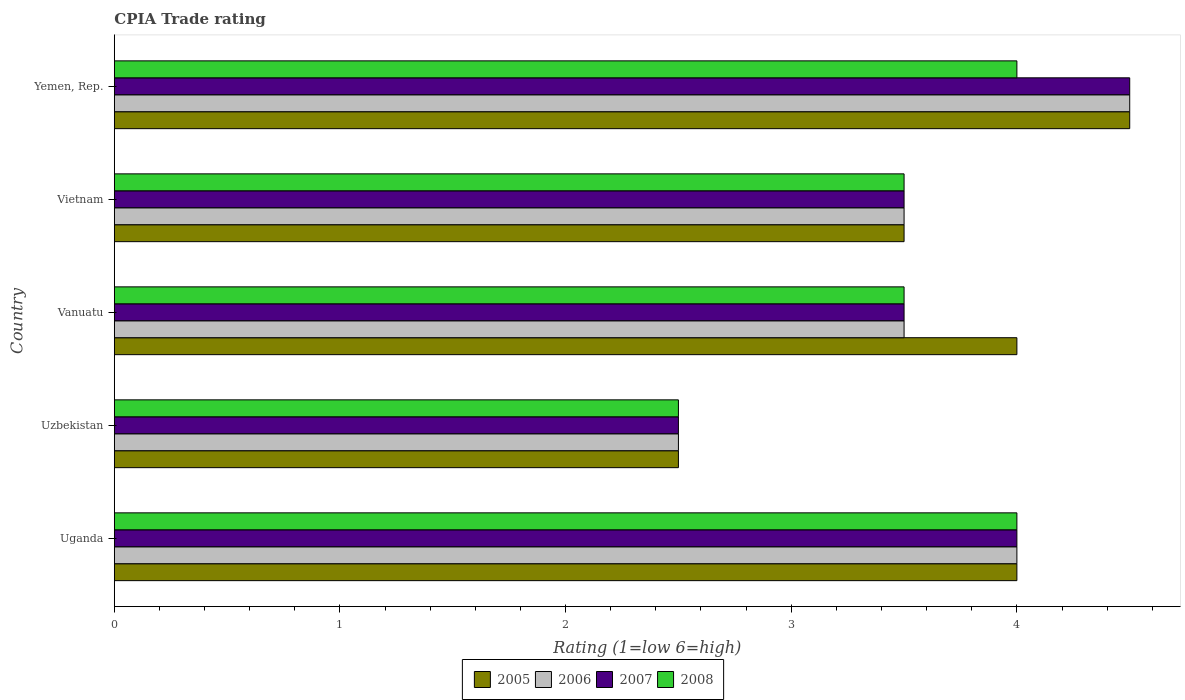How many different coloured bars are there?
Give a very brief answer. 4. How many groups of bars are there?
Keep it short and to the point. 5. Are the number of bars per tick equal to the number of legend labels?
Your answer should be compact. Yes. Are the number of bars on each tick of the Y-axis equal?
Keep it short and to the point. Yes. How many bars are there on the 1st tick from the top?
Provide a succinct answer. 4. What is the label of the 5th group of bars from the top?
Make the answer very short. Uganda. In how many cases, is the number of bars for a given country not equal to the number of legend labels?
Your response must be concise. 0. What is the CPIA rating in 2007 in Uzbekistan?
Your answer should be compact. 2.5. In which country was the CPIA rating in 2005 maximum?
Keep it short and to the point. Yemen, Rep. In which country was the CPIA rating in 2005 minimum?
Your response must be concise. Uzbekistan. What is the total CPIA rating in 2005 in the graph?
Your answer should be very brief. 18.5. What is the difference between the CPIA rating in 2006 in Uganda and the CPIA rating in 2005 in Vanuatu?
Your response must be concise. 0. What is the average CPIA rating in 2005 per country?
Give a very brief answer. 3.7. What is the difference between the CPIA rating in 2008 and CPIA rating in 2005 in Vanuatu?
Your answer should be very brief. -0.5. In how many countries, is the CPIA rating in 2008 greater than 0.2 ?
Offer a very short reply. 5. What is the ratio of the CPIA rating in 2007 in Uganda to that in Vanuatu?
Provide a succinct answer. 1.14. What is the difference between the highest and the second highest CPIA rating in 2007?
Offer a very short reply. 0.5. What is the difference between the highest and the lowest CPIA rating in 2008?
Provide a succinct answer. 1.5. What does the 4th bar from the top in Yemen, Rep. represents?
Your response must be concise. 2005. What does the 4th bar from the bottom in Uzbekistan represents?
Your answer should be very brief. 2008. Are all the bars in the graph horizontal?
Make the answer very short. Yes. How many countries are there in the graph?
Provide a succinct answer. 5. Does the graph contain any zero values?
Provide a succinct answer. No. Where does the legend appear in the graph?
Your answer should be compact. Bottom center. How many legend labels are there?
Make the answer very short. 4. How are the legend labels stacked?
Offer a terse response. Horizontal. What is the title of the graph?
Your answer should be very brief. CPIA Trade rating. Does "2015" appear as one of the legend labels in the graph?
Give a very brief answer. No. What is the label or title of the Y-axis?
Your answer should be very brief. Country. What is the Rating (1=low 6=high) of 2005 in Uzbekistan?
Make the answer very short. 2.5. What is the Rating (1=low 6=high) of 2006 in Uzbekistan?
Offer a terse response. 2.5. What is the Rating (1=low 6=high) in 2007 in Uzbekistan?
Your answer should be compact. 2.5. What is the Rating (1=low 6=high) in 2007 in Vanuatu?
Keep it short and to the point. 3.5. What is the Rating (1=low 6=high) in 2008 in Vanuatu?
Your answer should be compact. 3.5. What is the Rating (1=low 6=high) in 2006 in Vietnam?
Your answer should be very brief. 3.5. What is the Rating (1=low 6=high) of 2008 in Vietnam?
Your response must be concise. 3.5. What is the Rating (1=low 6=high) of 2005 in Yemen, Rep.?
Offer a terse response. 4.5. What is the Rating (1=low 6=high) in 2006 in Yemen, Rep.?
Offer a very short reply. 4.5. What is the Rating (1=low 6=high) in 2007 in Yemen, Rep.?
Give a very brief answer. 4.5. Across all countries, what is the maximum Rating (1=low 6=high) of 2005?
Provide a succinct answer. 4.5. Across all countries, what is the maximum Rating (1=low 6=high) of 2006?
Your answer should be compact. 4.5. Across all countries, what is the maximum Rating (1=low 6=high) in 2007?
Provide a succinct answer. 4.5. Across all countries, what is the maximum Rating (1=low 6=high) of 2008?
Offer a very short reply. 4. Across all countries, what is the minimum Rating (1=low 6=high) in 2008?
Give a very brief answer. 2.5. What is the total Rating (1=low 6=high) of 2006 in the graph?
Provide a succinct answer. 18. What is the total Rating (1=low 6=high) of 2007 in the graph?
Make the answer very short. 18. What is the total Rating (1=low 6=high) of 2008 in the graph?
Provide a short and direct response. 17.5. What is the difference between the Rating (1=low 6=high) of 2006 in Uganda and that in Uzbekistan?
Offer a very short reply. 1.5. What is the difference between the Rating (1=low 6=high) of 2007 in Uganda and that in Uzbekistan?
Your answer should be very brief. 1.5. What is the difference between the Rating (1=low 6=high) of 2008 in Uganda and that in Uzbekistan?
Offer a terse response. 1.5. What is the difference between the Rating (1=low 6=high) of 2005 in Uganda and that in Vanuatu?
Your answer should be compact. 0. What is the difference between the Rating (1=low 6=high) in 2006 in Uganda and that in Vanuatu?
Provide a succinct answer. 0.5. What is the difference between the Rating (1=low 6=high) of 2007 in Uganda and that in Vanuatu?
Make the answer very short. 0.5. What is the difference between the Rating (1=low 6=high) of 2008 in Uganda and that in Vanuatu?
Keep it short and to the point. 0.5. What is the difference between the Rating (1=low 6=high) of 2006 in Uganda and that in Vietnam?
Provide a short and direct response. 0.5. What is the difference between the Rating (1=low 6=high) of 2007 in Uganda and that in Vietnam?
Make the answer very short. 0.5. What is the difference between the Rating (1=low 6=high) in 2008 in Uganda and that in Vietnam?
Your answer should be very brief. 0.5. What is the difference between the Rating (1=low 6=high) in 2007 in Uganda and that in Yemen, Rep.?
Your answer should be very brief. -0.5. What is the difference between the Rating (1=low 6=high) in 2008 in Uganda and that in Yemen, Rep.?
Make the answer very short. 0. What is the difference between the Rating (1=low 6=high) of 2005 in Uzbekistan and that in Vanuatu?
Your answer should be compact. -1.5. What is the difference between the Rating (1=low 6=high) of 2007 in Uzbekistan and that in Vanuatu?
Your answer should be compact. -1. What is the difference between the Rating (1=low 6=high) in 2008 in Uzbekistan and that in Vanuatu?
Provide a short and direct response. -1. What is the difference between the Rating (1=low 6=high) of 2007 in Uzbekistan and that in Vietnam?
Your answer should be very brief. -1. What is the difference between the Rating (1=low 6=high) of 2008 in Uzbekistan and that in Vietnam?
Offer a very short reply. -1. What is the difference between the Rating (1=low 6=high) in 2006 in Uzbekistan and that in Yemen, Rep.?
Keep it short and to the point. -2. What is the difference between the Rating (1=low 6=high) of 2007 in Uzbekistan and that in Yemen, Rep.?
Your answer should be very brief. -2. What is the difference between the Rating (1=low 6=high) in 2008 in Uzbekistan and that in Yemen, Rep.?
Give a very brief answer. -1.5. What is the difference between the Rating (1=low 6=high) of 2005 in Vanuatu and that in Vietnam?
Your response must be concise. 0.5. What is the difference between the Rating (1=low 6=high) of 2007 in Vanuatu and that in Vietnam?
Provide a short and direct response. 0. What is the difference between the Rating (1=low 6=high) in 2008 in Vanuatu and that in Vietnam?
Give a very brief answer. 0. What is the difference between the Rating (1=low 6=high) of 2006 in Vanuatu and that in Yemen, Rep.?
Offer a very short reply. -1. What is the difference between the Rating (1=low 6=high) of 2008 in Vanuatu and that in Yemen, Rep.?
Provide a short and direct response. -0.5. What is the difference between the Rating (1=low 6=high) in 2007 in Vietnam and that in Yemen, Rep.?
Provide a succinct answer. -1. What is the difference between the Rating (1=low 6=high) in 2005 in Uganda and the Rating (1=low 6=high) in 2007 in Uzbekistan?
Offer a very short reply. 1.5. What is the difference between the Rating (1=low 6=high) in 2007 in Uganda and the Rating (1=low 6=high) in 2008 in Uzbekistan?
Your response must be concise. 1.5. What is the difference between the Rating (1=low 6=high) in 2005 in Uganda and the Rating (1=low 6=high) in 2008 in Vanuatu?
Provide a short and direct response. 0.5. What is the difference between the Rating (1=low 6=high) in 2006 in Uganda and the Rating (1=low 6=high) in 2007 in Vanuatu?
Ensure brevity in your answer.  0.5. What is the difference between the Rating (1=low 6=high) in 2005 in Uganda and the Rating (1=low 6=high) in 2008 in Vietnam?
Your answer should be compact. 0.5. What is the difference between the Rating (1=low 6=high) in 2006 in Uganda and the Rating (1=low 6=high) in 2008 in Vietnam?
Make the answer very short. 0.5. What is the difference between the Rating (1=low 6=high) of 2007 in Uganda and the Rating (1=low 6=high) of 2008 in Vietnam?
Offer a terse response. 0.5. What is the difference between the Rating (1=low 6=high) of 2005 in Uganda and the Rating (1=low 6=high) of 2006 in Yemen, Rep.?
Your response must be concise. -0.5. What is the difference between the Rating (1=low 6=high) in 2005 in Uganda and the Rating (1=low 6=high) in 2008 in Yemen, Rep.?
Ensure brevity in your answer.  0. What is the difference between the Rating (1=low 6=high) in 2006 in Uganda and the Rating (1=low 6=high) in 2007 in Yemen, Rep.?
Your answer should be very brief. -0.5. What is the difference between the Rating (1=low 6=high) in 2006 in Uganda and the Rating (1=low 6=high) in 2008 in Yemen, Rep.?
Give a very brief answer. 0. What is the difference between the Rating (1=low 6=high) in 2007 in Uganda and the Rating (1=low 6=high) in 2008 in Yemen, Rep.?
Offer a terse response. 0. What is the difference between the Rating (1=low 6=high) of 2005 in Uzbekistan and the Rating (1=low 6=high) of 2007 in Vanuatu?
Keep it short and to the point. -1. What is the difference between the Rating (1=low 6=high) of 2005 in Uzbekistan and the Rating (1=low 6=high) of 2008 in Vanuatu?
Your answer should be compact. -1. What is the difference between the Rating (1=low 6=high) in 2006 in Uzbekistan and the Rating (1=low 6=high) in 2007 in Vanuatu?
Give a very brief answer. -1. What is the difference between the Rating (1=low 6=high) of 2006 in Uzbekistan and the Rating (1=low 6=high) of 2008 in Vanuatu?
Your answer should be very brief. -1. What is the difference between the Rating (1=low 6=high) in 2007 in Uzbekistan and the Rating (1=low 6=high) in 2008 in Vanuatu?
Make the answer very short. -1. What is the difference between the Rating (1=low 6=high) of 2005 in Uzbekistan and the Rating (1=low 6=high) of 2006 in Vietnam?
Keep it short and to the point. -1. What is the difference between the Rating (1=low 6=high) in 2005 in Uzbekistan and the Rating (1=low 6=high) in 2007 in Vietnam?
Your answer should be very brief. -1. What is the difference between the Rating (1=low 6=high) in 2005 in Uzbekistan and the Rating (1=low 6=high) in 2008 in Vietnam?
Provide a short and direct response. -1. What is the difference between the Rating (1=low 6=high) of 2006 in Uzbekistan and the Rating (1=low 6=high) of 2007 in Vietnam?
Offer a terse response. -1. What is the difference between the Rating (1=low 6=high) in 2006 in Uzbekistan and the Rating (1=low 6=high) in 2008 in Vietnam?
Your response must be concise. -1. What is the difference between the Rating (1=low 6=high) in 2005 in Uzbekistan and the Rating (1=low 6=high) in 2007 in Yemen, Rep.?
Make the answer very short. -2. What is the difference between the Rating (1=low 6=high) in 2007 in Uzbekistan and the Rating (1=low 6=high) in 2008 in Yemen, Rep.?
Provide a short and direct response. -1.5. What is the difference between the Rating (1=low 6=high) of 2005 in Vanuatu and the Rating (1=low 6=high) of 2006 in Vietnam?
Your answer should be very brief. 0.5. What is the difference between the Rating (1=low 6=high) in 2005 in Vanuatu and the Rating (1=low 6=high) in 2007 in Vietnam?
Your response must be concise. 0.5. What is the difference between the Rating (1=low 6=high) of 2006 in Vanuatu and the Rating (1=low 6=high) of 2007 in Vietnam?
Your answer should be very brief. 0. What is the difference between the Rating (1=low 6=high) in 2006 in Vanuatu and the Rating (1=low 6=high) in 2008 in Vietnam?
Ensure brevity in your answer.  0. What is the difference between the Rating (1=low 6=high) of 2005 in Vanuatu and the Rating (1=low 6=high) of 2006 in Yemen, Rep.?
Provide a short and direct response. -0.5. What is the difference between the Rating (1=low 6=high) of 2005 in Vanuatu and the Rating (1=low 6=high) of 2007 in Yemen, Rep.?
Your answer should be very brief. -0.5. What is the difference between the Rating (1=low 6=high) in 2006 in Vanuatu and the Rating (1=low 6=high) in 2007 in Yemen, Rep.?
Make the answer very short. -1. What is the difference between the Rating (1=low 6=high) of 2006 in Vanuatu and the Rating (1=low 6=high) of 2008 in Yemen, Rep.?
Keep it short and to the point. -0.5. What is the difference between the Rating (1=low 6=high) in 2005 in Vietnam and the Rating (1=low 6=high) in 2007 in Yemen, Rep.?
Your response must be concise. -1. What is the difference between the Rating (1=low 6=high) of 2005 in Vietnam and the Rating (1=low 6=high) of 2008 in Yemen, Rep.?
Your answer should be very brief. -0.5. What is the average Rating (1=low 6=high) of 2006 per country?
Give a very brief answer. 3.6. What is the average Rating (1=low 6=high) of 2007 per country?
Give a very brief answer. 3.6. What is the average Rating (1=low 6=high) in 2008 per country?
Ensure brevity in your answer.  3.5. What is the difference between the Rating (1=low 6=high) of 2007 and Rating (1=low 6=high) of 2008 in Uganda?
Make the answer very short. 0. What is the difference between the Rating (1=low 6=high) of 2005 and Rating (1=low 6=high) of 2006 in Uzbekistan?
Offer a terse response. 0. What is the difference between the Rating (1=low 6=high) in 2007 and Rating (1=low 6=high) in 2008 in Uzbekistan?
Make the answer very short. 0. What is the difference between the Rating (1=low 6=high) of 2005 and Rating (1=low 6=high) of 2007 in Vanuatu?
Offer a terse response. 0.5. What is the difference between the Rating (1=low 6=high) of 2005 and Rating (1=low 6=high) of 2008 in Vanuatu?
Provide a short and direct response. 0.5. What is the difference between the Rating (1=low 6=high) in 2005 and Rating (1=low 6=high) in 2006 in Vietnam?
Keep it short and to the point. 0. What is the difference between the Rating (1=low 6=high) in 2005 and Rating (1=low 6=high) in 2007 in Vietnam?
Your answer should be very brief. 0. What is the difference between the Rating (1=low 6=high) of 2006 and Rating (1=low 6=high) of 2008 in Vietnam?
Offer a very short reply. 0. What is the difference between the Rating (1=low 6=high) in 2005 and Rating (1=low 6=high) in 2006 in Yemen, Rep.?
Offer a very short reply. 0. What is the difference between the Rating (1=low 6=high) of 2005 and Rating (1=low 6=high) of 2007 in Yemen, Rep.?
Offer a terse response. 0. What is the difference between the Rating (1=low 6=high) in 2005 and Rating (1=low 6=high) in 2008 in Yemen, Rep.?
Give a very brief answer. 0.5. What is the ratio of the Rating (1=low 6=high) in 2007 in Uganda to that in Uzbekistan?
Your answer should be compact. 1.6. What is the ratio of the Rating (1=low 6=high) of 2005 in Uganda to that in Vanuatu?
Provide a short and direct response. 1. What is the ratio of the Rating (1=low 6=high) of 2008 in Uganda to that in Vanuatu?
Give a very brief answer. 1.14. What is the ratio of the Rating (1=low 6=high) in 2005 in Uganda to that in Vietnam?
Your answer should be compact. 1.14. What is the ratio of the Rating (1=low 6=high) of 2007 in Uganda to that in Yemen, Rep.?
Keep it short and to the point. 0.89. What is the ratio of the Rating (1=low 6=high) of 2008 in Uganda to that in Yemen, Rep.?
Provide a short and direct response. 1. What is the ratio of the Rating (1=low 6=high) in 2005 in Uzbekistan to that in Vanuatu?
Provide a short and direct response. 0.62. What is the ratio of the Rating (1=low 6=high) in 2006 in Uzbekistan to that in Vanuatu?
Your response must be concise. 0.71. What is the ratio of the Rating (1=low 6=high) in 2007 in Uzbekistan to that in Vanuatu?
Offer a very short reply. 0.71. What is the ratio of the Rating (1=low 6=high) of 2005 in Uzbekistan to that in Vietnam?
Keep it short and to the point. 0.71. What is the ratio of the Rating (1=low 6=high) in 2006 in Uzbekistan to that in Vietnam?
Provide a short and direct response. 0.71. What is the ratio of the Rating (1=low 6=high) of 2007 in Uzbekistan to that in Vietnam?
Make the answer very short. 0.71. What is the ratio of the Rating (1=low 6=high) in 2008 in Uzbekistan to that in Vietnam?
Keep it short and to the point. 0.71. What is the ratio of the Rating (1=low 6=high) of 2005 in Uzbekistan to that in Yemen, Rep.?
Give a very brief answer. 0.56. What is the ratio of the Rating (1=low 6=high) of 2006 in Uzbekistan to that in Yemen, Rep.?
Provide a succinct answer. 0.56. What is the ratio of the Rating (1=low 6=high) in 2007 in Uzbekistan to that in Yemen, Rep.?
Offer a terse response. 0.56. What is the ratio of the Rating (1=low 6=high) in 2005 in Vanuatu to that in Vietnam?
Your answer should be compact. 1.14. What is the ratio of the Rating (1=low 6=high) in 2006 in Vanuatu to that in Vietnam?
Keep it short and to the point. 1. What is the ratio of the Rating (1=low 6=high) in 2008 in Vanuatu to that in Vietnam?
Provide a succinct answer. 1. What is the ratio of the Rating (1=low 6=high) of 2005 in Vanuatu to that in Yemen, Rep.?
Give a very brief answer. 0.89. What is the ratio of the Rating (1=low 6=high) of 2007 in Vanuatu to that in Yemen, Rep.?
Your answer should be very brief. 0.78. What is the ratio of the Rating (1=low 6=high) in 2008 in Vanuatu to that in Yemen, Rep.?
Give a very brief answer. 0.88. What is the ratio of the Rating (1=low 6=high) in 2005 in Vietnam to that in Yemen, Rep.?
Your answer should be compact. 0.78. What is the ratio of the Rating (1=low 6=high) of 2006 in Vietnam to that in Yemen, Rep.?
Provide a short and direct response. 0.78. What is the difference between the highest and the second highest Rating (1=low 6=high) in 2005?
Provide a short and direct response. 0.5. What is the difference between the highest and the second highest Rating (1=low 6=high) in 2007?
Offer a very short reply. 0.5. What is the difference between the highest and the second highest Rating (1=low 6=high) in 2008?
Offer a very short reply. 0. What is the difference between the highest and the lowest Rating (1=low 6=high) in 2005?
Offer a terse response. 2. What is the difference between the highest and the lowest Rating (1=low 6=high) of 2006?
Give a very brief answer. 2. What is the difference between the highest and the lowest Rating (1=low 6=high) of 2007?
Offer a terse response. 2. What is the difference between the highest and the lowest Rating (1=low 6=high) of 2008?
Provide a short and direct response. 1.5. 